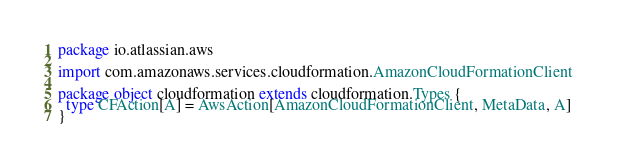<code> <loc_0><loc_0><loc_500><loc_500><_Scala_>package io.atlassian.aws

import com.amazonaws.services.cloudformation.AmazonCloudFormationClient

package object cloudformation extends cloudformation.Types {
  type CFAction[A] = AwsAction[AmazonCloudFormationClient, MetaData, A]
}
</code> 